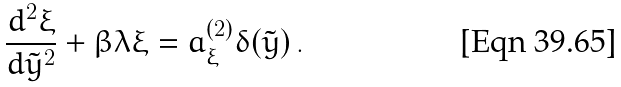<formula> <loc_0><loc_0><loc_500><loc_500>\frac { d ^ { 2 } \xi } { d \tilde { y } ^ { 2 } } + \beta \lambda \xi = a ^ { ( 2 ) } _ { \xi } \delta ( \tilde { y } ) \, .</formula> 